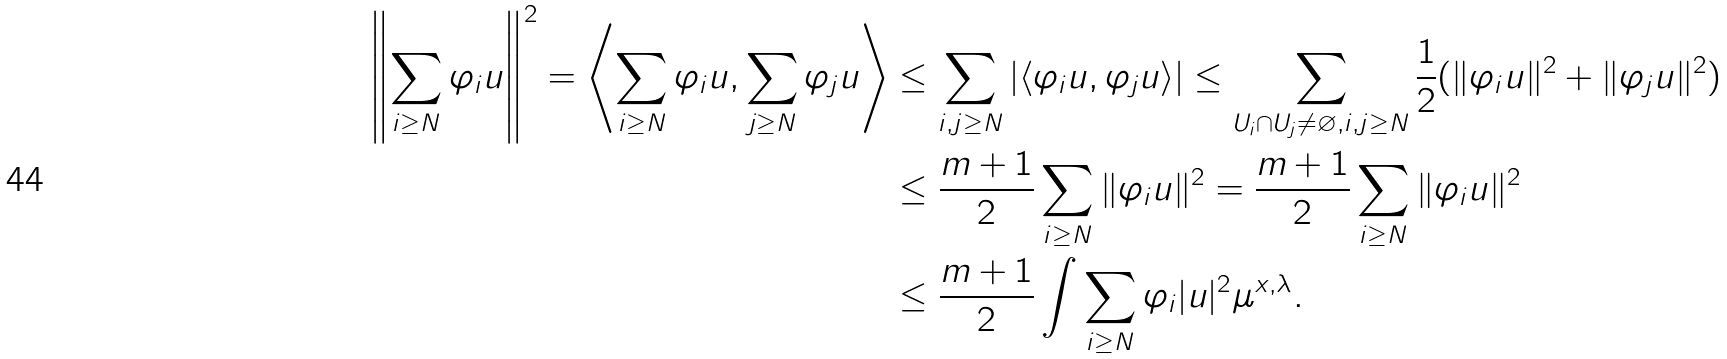<formula> <loc_0><loc_0><loc_500><loc_500>\left \| \sum _ { i \geq N } \varphi _ { i } u \right \| ^ { 2 } = \left \langle \sum _ { i \geq N } \varphi _ { i } u , \sum _ { j \geq N } \varphi _ { j } u \right \rangle & \leq \sum _ { i , j \geq N } | \langle \varphi _ { i } u , \varphi _ { j } u \rangle | \leq \sum _ { U _ { i } \cap U _ { j } \ne \varnothing , i , j \geq N } \frac { 1 } { 2 } ( \| \varphi _ { i } u \| ^ { 2 } + \| \varphi _ { j } u \| ^ { 2 } ) \\ & \leq \frac { m + 1 } { 2 } \sum _ { i \geq N } \| \varphi _ { i } u \| ^ { 2 } = \frac { m + 1 } { 2 } \sum _ { i \geq N } \| \varphi _ { i } u \| ^ { 2 } \\ & \leq \frac { m + 1 } { 2 } \int \sum _ { i \geq N } \varphi _ { i } | u | ^ { 2 } \mu ^ { x , \lambda } .</formula> 